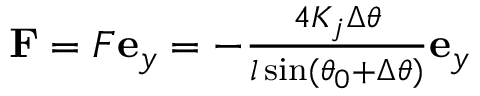<formula> <loc_0><loc_0><loc_500><loc_500>\begin{array} { r } { F = F e _ { y } = - \frac { 4 K _ { j } \Delta \theta } { l \sin ( \theta _ { 0 } + \Delta \theta ) } e _ { y } } \end{array}</formula> 